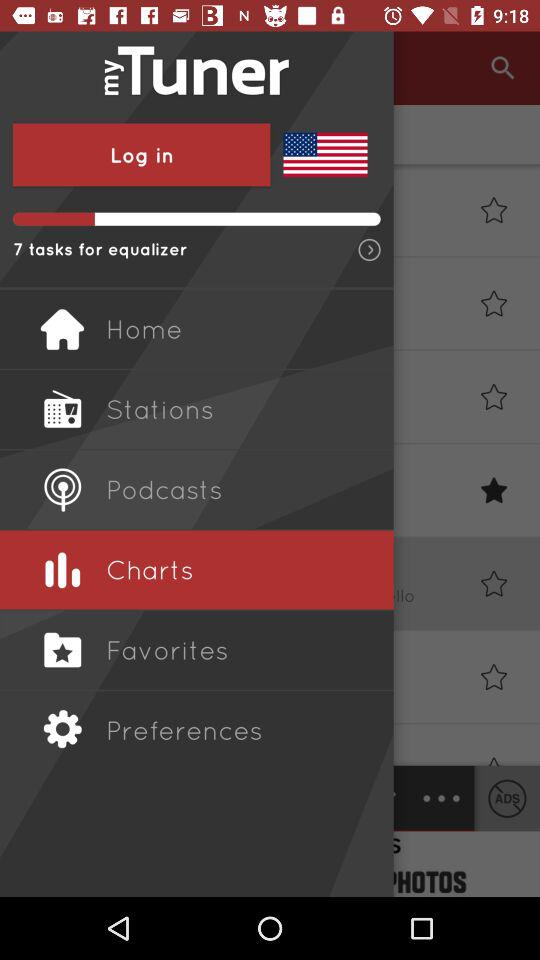What is the app name? The app name is "myTuner". 